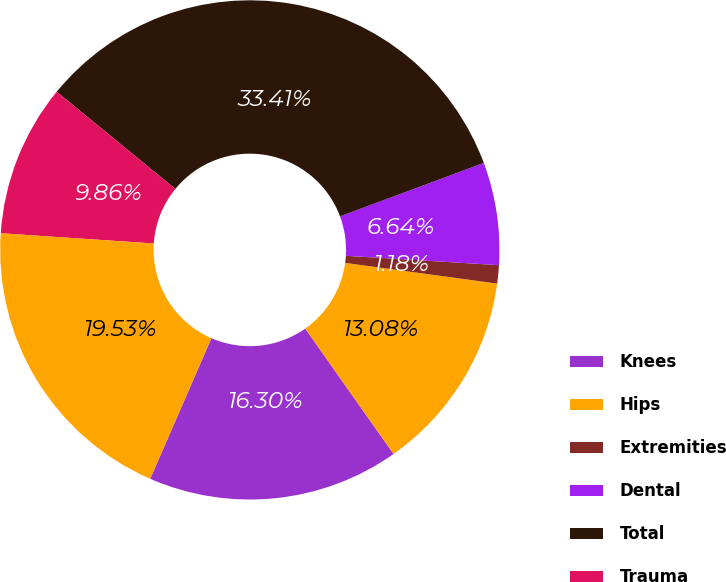Convert chart to OTSL. <chart><loc_0><loc_0><loc_500><loc_500><pie_chart><fcel>Knees<fcel>Hips<fcel>Extremities<fcel>Dental<fcel>Total<fcel>Trauma<fcel>Spine<nl><fcel>16.3%<fcel>13.08%<fcel>1.18%<fcel>6.64%<fcel>33.41%<fcel>9.86%<fcel>19.53%<nl></chart> 